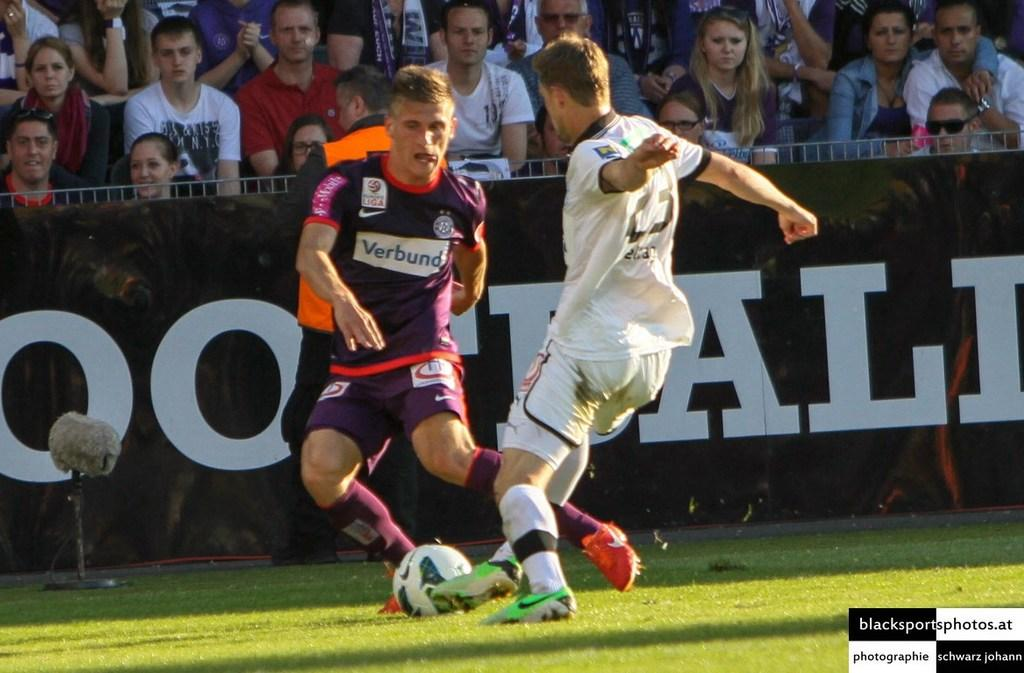<image>
Describe the image concisely. The shot of the two footballers vying for the soccer ball was supplied by blacksportsphotos.at. 